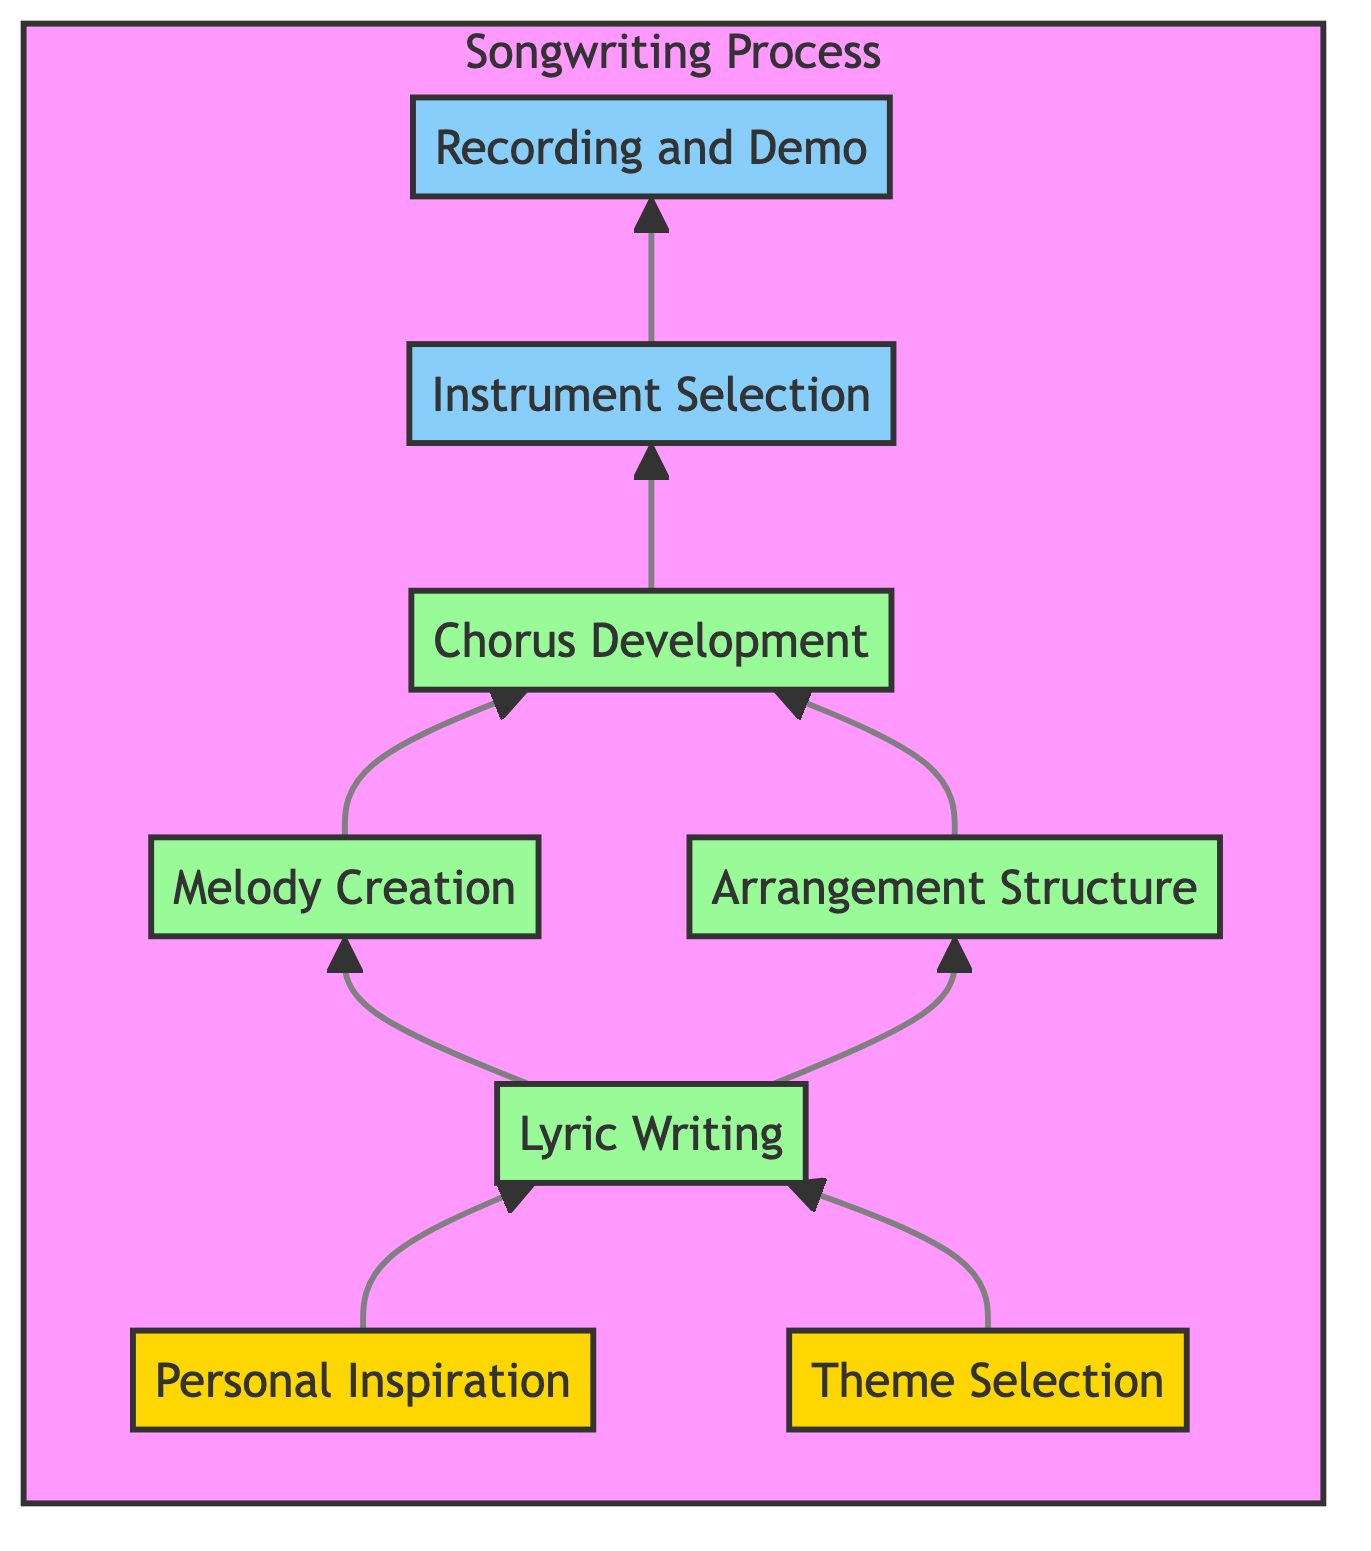What is the first step in the songwriting process? The first step in the diagram is "Personal Inspiration," which is where the process begins by drawing from personal experiences.
Answer: Personal Inspiration How many main steps are there before recording? The steps before recording are Personal Inspiration, Theme Selection, Lyric Writing, Melody Creation, Arrangement Structure, Chorus Development, and Instrument Selection, totaling seven steps.
Answer: Seven Which step directly follows Lyric Writing? According to the diagram, the step that directly follows "Lyric Writing" is "Melody Creation."
Answer: Melody Creation What two elements inspire the "Theme Selection"? The "Theme Selection" is inspired by "Personal Inspiration" and is also linked to the central theme chosen for the song.
Answer: Personal Inspiration and central theme What is the purpose of "Chorus Development"? The purpose of "Chorus Development" is to create a memorable chorus that captures the essence of the song.
Answer: Create a memorable chorus What is the final step in the songwriting process? The final step in the process, as depicted in the diagram, is "Recording and Demo."
Answer: Recording and Demo How many nodes are in the diagram representing the arrangement steps? The diagram has three nodes representing the arrangement steps: Arrangement Structure, Chorus Development, and Instrument Selection.
Answer: Three Which two steps lead to "Chorus Development"? "Lyric Writing" and "Arrangement Structure" both lead to "Chorus Development" in the flowchart.
Answer: Lyric Writing and Arrangement Structure 